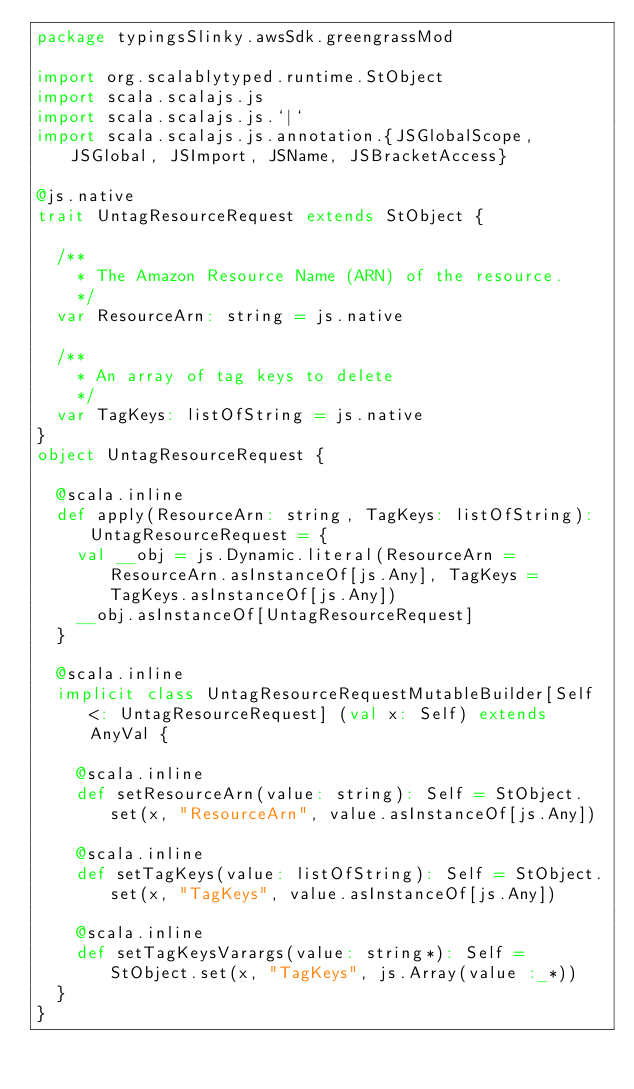Convert code to text. <code><loc_0><loc_0><loc_500><loc_500><_Scala_>package typingsSlinky.awsSdk.greengrassMod

import org.scalablytyped.runtime.StObject
import scala.scalajs.js
import scala.scalajs.js.`|`
import scala.scalajs.js.annotation.{JSGlobalScope, JSGlobal, JSImport, JSName, JSBracketAccess}

@js.native
trait UntagResourceRequest extends StObject {
  
  /**
    * The Amazon Resource Name (ARN) of the resource.
    */
  var ResourceArn: string = js.native
  
  /**
    * An array of tag keys to delete
    */
  var TagKeys: listOfString = js.native
}
object UntagResourceRequest {
  
  @scala.inline
  def apply(ResourceArn: string, TagKeys: listOfString): UntagResourceRequest = {
    val __obj = js.Dynamic.literal(ResourceArn = ResourceArn.asInstanceOf[js.Any], TagKeys = TagKeys.asInstanceOf[js.Any])
    __obj.asInstanceOf[UntagResourceRequest]
  }
  
  @scala.inline
  implicit class UntagResourceRequestMutableBuilder[Self <: UntagResourceRequest] (val x: Self) extends AnyVal {
    
    @scala.inline
    def setResourceArn(value: string): Self = StObject.set(x, "ResourceArn", value.asInstanceOf[js.Any])
    
    @scala.inline
    def setTagKeys(value: listOfString): Self = StObject.set(x, "TagKeys", value.asInstanceOf[js.Any])
    
    @scala.inline
    def setTagKeysVarargs(value: string*): Self = StObject.set(x, "TagKeys", js.Array(value :_*))
  }
}
</code> 